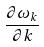Convert formula to latex. <formula><loc_0><loc_0><loc_500><loc_500>\frac { \partial \omega _ { k } } { \partial k }</formula> 